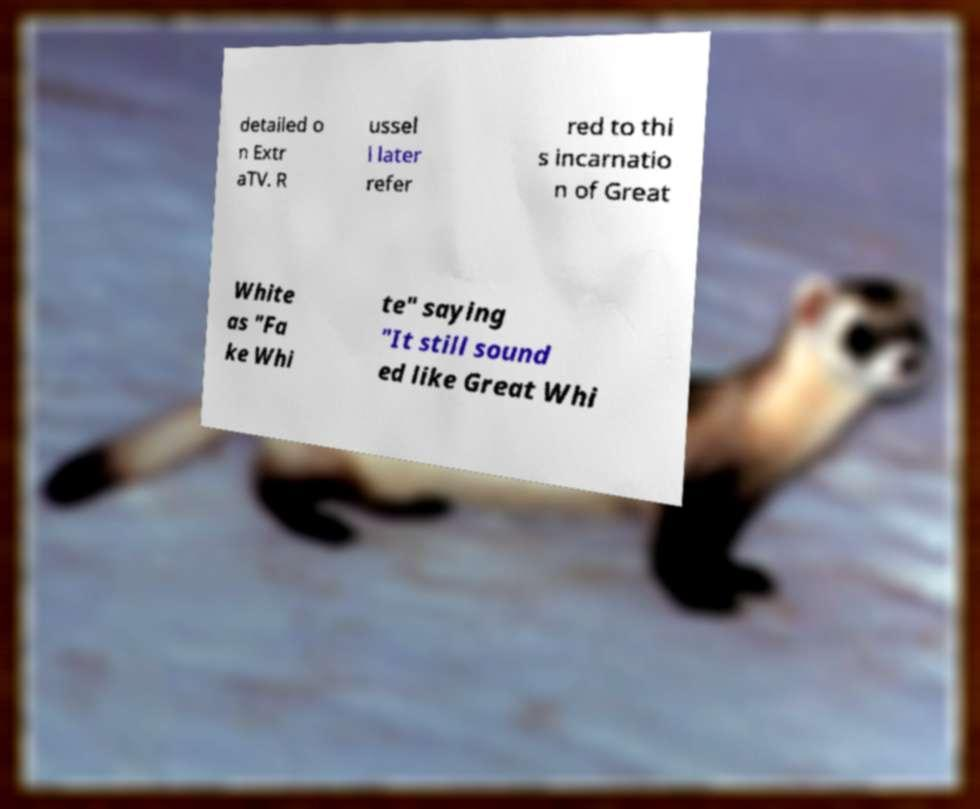What messages or text are displayed in this image? I need them in a readable, typed format. detailed o n Extr aTV. R ussel l later refer red to thi s incarnatio n of Great White as "Fa ke Whi te" saying "It still sound ed like Great Whi 